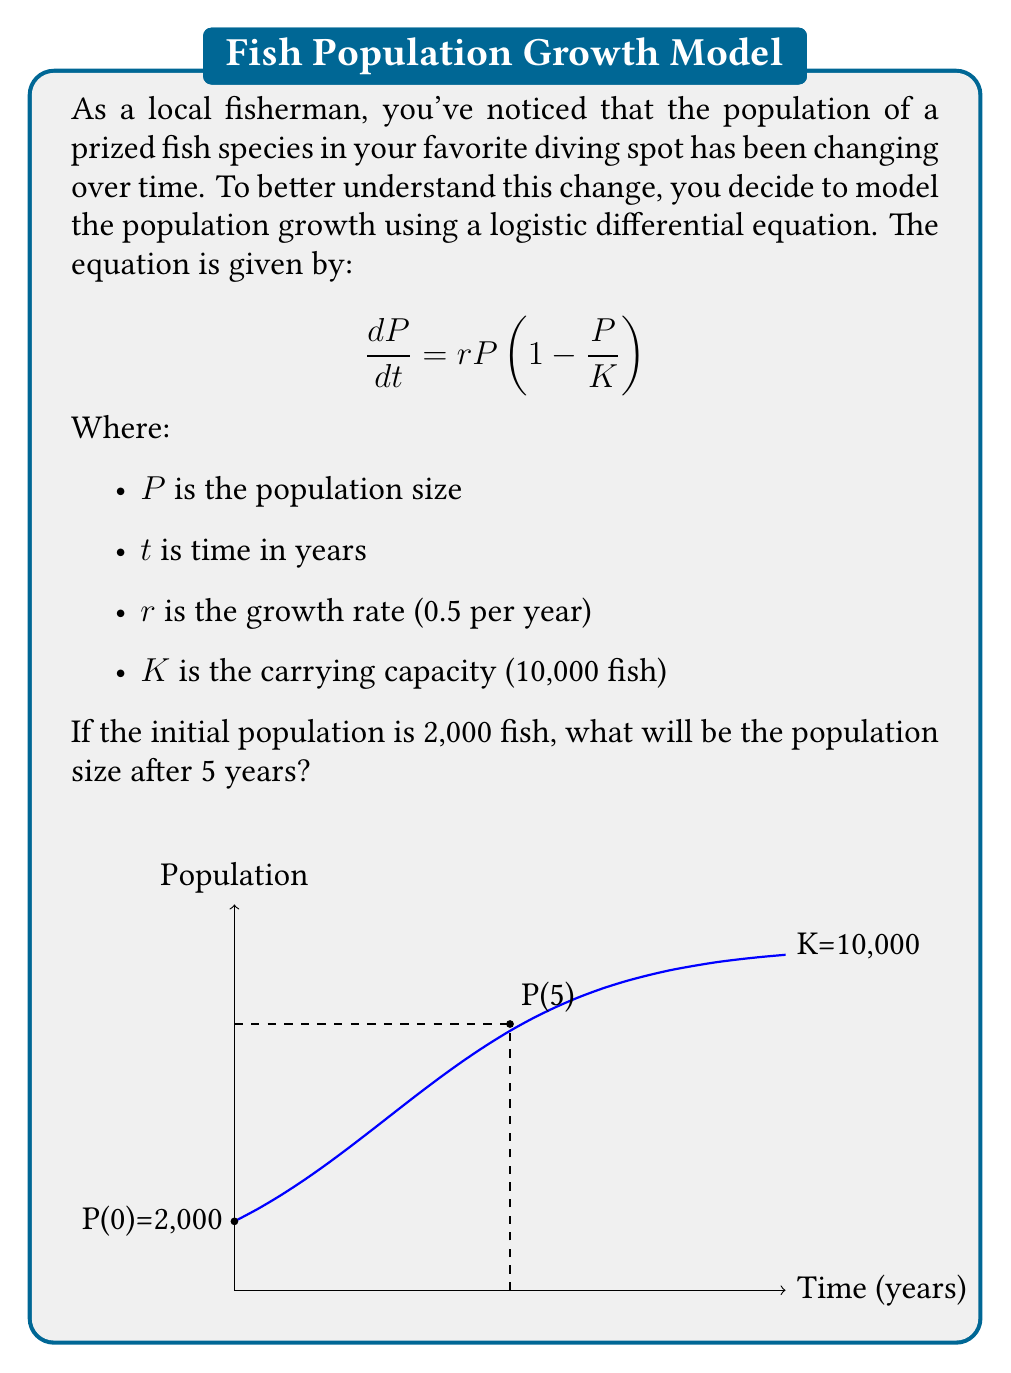Can you solve this math problem? To solve this problem, we need to use the solution to the logistic differential equation:

$$P(t) = \frac{K}{1 + (\frac{K}{P_0} - 1)e^{-rt}}$$

Where $P_0$ is the initial population.

Let's follow these steps:

1) First, let's substitute the known values:
   $K = 10,000$
   $r = 0.5$
   $P_0 = 2,000$
   $t = 5$

2) Now, let's plug these into our equation:

   $$P(5) = \frac{10,000}{1 + (\frac{10,000}{2,000} - 1)e^{-0.5(5)}}$$

3) Simplify the fraction inside the parentheses:

   $$P(5) = \frac{10,000}{1 + (5 - 1)e^{-2.5}}$$

4) Simplify further:

   $$P(5) = \frac{10,000}{1 + 4e^{-2.5}}$$

5) Calculate $e^{-2.5}$:

   $$P(5) = \frac{10,000}{1 + 4(0.0821)}$$

6) Simplify:

   $$P(5) = \frac{10,000}{1 + 0.3284}$$

7) Calculate the final result:

   $$P(5) = \frac{10,000}{1.3284} \approx 7,528$$

Therefore, after 5 years, the population will be approximately 7,528 fish.
Answer: 7,528 fish 